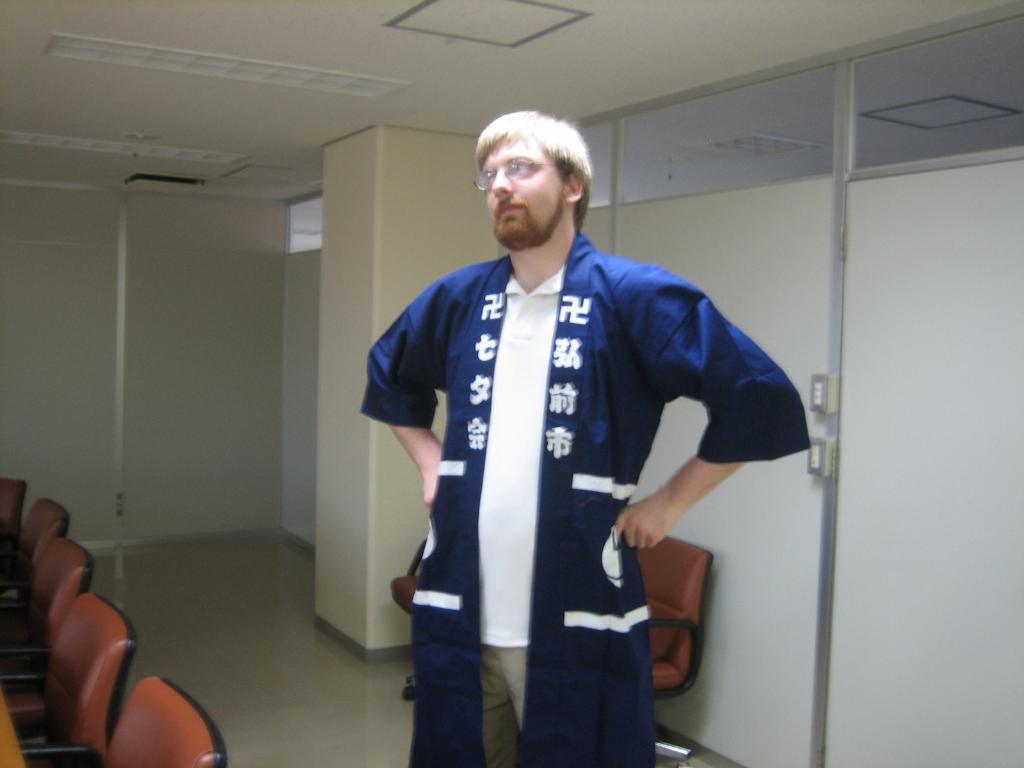Please provide a concise description of this image. In this picture there is a man who is wearing shirt, trouser and jacket. He is standing near to the chairs. On the left I can see the chair, table and door. On the right I can see the partition. Behind him I can see some other chairs which are placed near to the pillar. On the roof I can see the lights. 